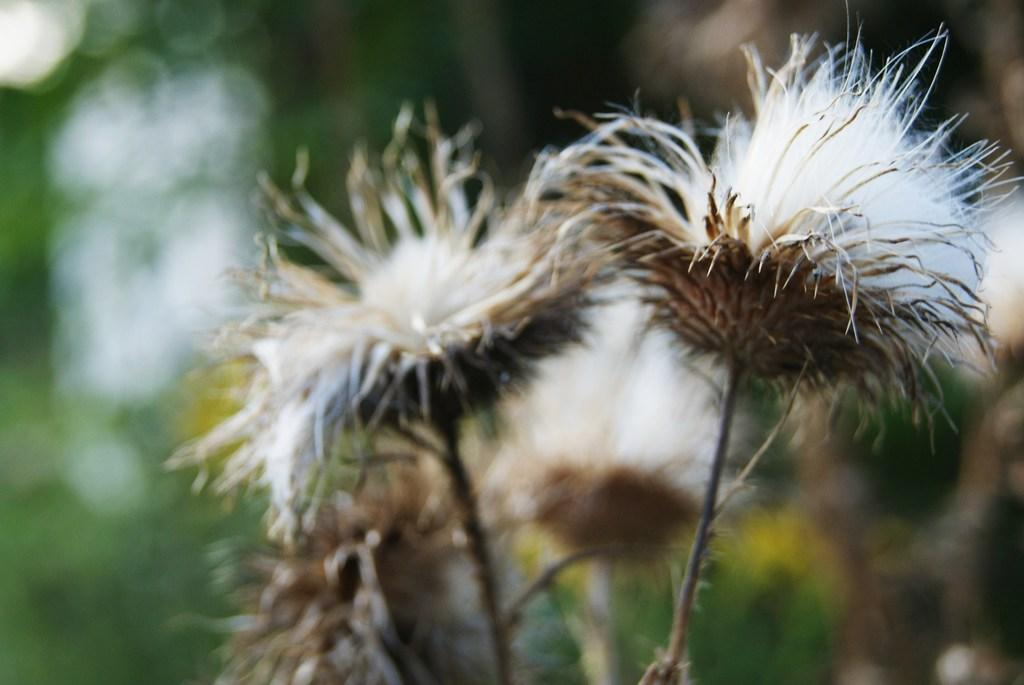What is the condition of the flowers in the image? The flowers in the image are dried. What type of star can be seen in the image? There is no star present in the image; it features dried flowers. What is the route taken by the soldiers in the image? There is no reference to soldiers or a route in the image, as it only features dried flowers. 